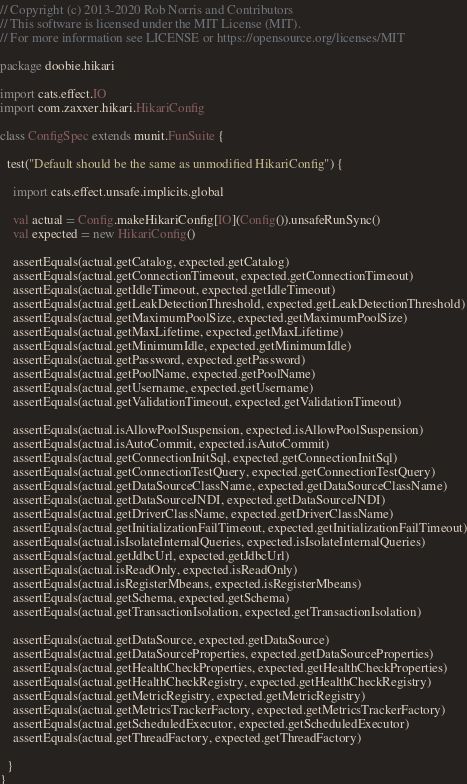<code> <loc_0><loc_0><loc_500><loc_500><_Scala_>// Copyright (c) 2013-2020 Rob Norris and Contributors
// This software is licensed under the MIT License (MIT).
// For more information see LICENSE or https://opensource.org/licenses/MIT

package doobie.hikari

import cats.effect.IO
import com.zaxxer.hikari.HikariConfig

class ConfigSpec extends munit.FunSuite {

  test("Default should be the same as unmodified HikariConfig") {

    import cats.effect.unsafe.implicits.global

    val actual = Config.makeHikariConfig[IO](Config()).unsafeRunSync()
    val expected = new HikariConfig()

    assertEquals(actual.getCatalog, expected.getCatalog)
    assertEquals(actual.getConnectionTimeout, expected.getConnectionTimeout)
    assertEquals(actual.getIdleTimeout, expected.getIdleTimeout)
    assertEquals(actual.getLeakDetectionThreshold, expected.getLeakDetectionThreshold)
    assertEquals(actual.getMaximumPoolSize, expected.getMaximumPoolSize)
    assertEquals(actual.getMaxLifetime, expected.getMaxLifetime)
    assertEquals(actual.getMinimumIdle, expected.getMinimumIdle)
    assertEquals(actual.getPassword, expected.getPassword)
    assertEquals(actual.getPoolName, expected.getPoolName)
    assertEquals(actual.getUsername, expected.getUsername)
    assertEquals(actual.getValidationTimeout, expected.getValidationTimeout)

    assertEquals(actual.isAllowPoolSuspension, expected.isAllowPoolSuspension)
    assertEquals(actual.isAutoCommit, expected.isAutoCommit)
    assertEquals(actual.getConnectionInitSql, expected.getConnectionInitSql)
    assertEquals(actual.getConnectionTestQuery, expected.getConnectionTestQuery)
    assertEquals(actual.getDataSourceClassName, expected.getDataSourceClassName)
    assertEquals(actual.getDataSourceJNDI, expected.getDataSourceJNDI)
    assertEquals(actual.getDriverClassName, expected.getDriverClassName)
    assertEquals(actual.getInitializationFailTimeout, expected.getInitializationFailTimeout)
    assertEquals(actual.isIsolateInternalQueries, expected.isIsolateInternalQueries)
    assertEquals(actual.getJdbcUrl, expected.getJdbcUrl)
    assertEquals(actual.isReadOnly, expected.isReadOnly)
    assertEquals(actual.isRegisterMbeans, expected.isRegisterMbeans)
    assertEquals(actual.getSchema, expected.getSchema)
    assertEquals(actual.getTransactionIsolation, expected.getTransactionIsolation)

    assertEquals(actual.getDataSource, expected.getDataSource)
    assertEquals(actual.getDataSourceProperties, expected.getDataSourceProperties)
    assertEquals(actual.getHealthCheckProperties, expected.getHealthCheckProperties)
    assertEquals(actual.getHealthCheckRegistry, expected.getHealthCheckRegistry)
    assertEquals(actual.getMetricRegistry, expected.getMetricRegistry)
    assertEquals(actual.getMetricsTrackerFactory, expected.getMetricsTrackerFactory)
    assertEquals(actual.getScheduledExecutor, expected.getScheduledExecutor)
    assertEquals(actual.getThreadFactory, expected.getThreadFactory)

  }
}
</code> 